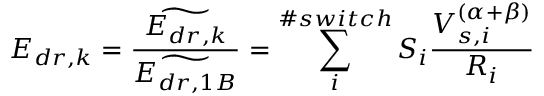Convert formula to latex. <formula><loc_0><loc_0><loc_500><loc_500>E _ { d r , k } = \frac { \widetilde { E _ { d r , k } } } { \widetilde { E _ { d r , 1 B } } } = \sum _ { i } ^ { \# s w i t c h } S _ { i } \frac { V _ { s , i } ^ { ( \alpha + \beta ) } } { R _ { i } }</formula> 